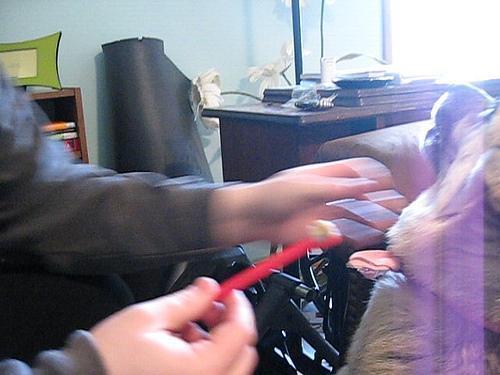What is the person trying to do to the dog?
Choose the right answer from the provided options to respond to the question.
Options: Brush teeth, clean eyes, tighten color, cut nails. Brush teeth. 